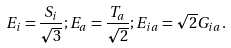<formula> <loc_0><loc_0><loc_500><loc_500>E _ { i } = \frac { S _ { i } } { \sqrt { 3 } } ; E _ { a } = \frac { T _ { a } } { \sqrt { 2 } } ; E _ { i a } = \sqrt { 2 } G _ { i a } .</formula> 